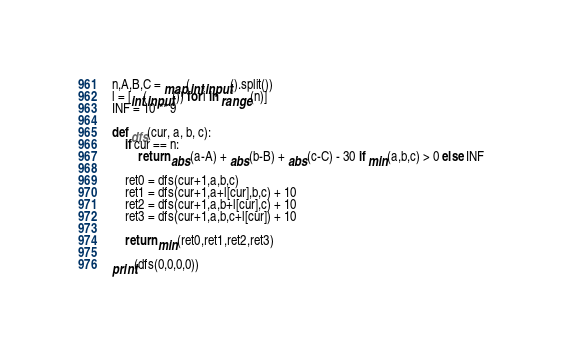Convert code to text. <code><loc_0><loc_0><loc_500><loc_500><_Python_>n,A,B,C = map(int,input().split())
l = [int(input()) for i in range(n)]
INF = 10 ** 9

def dfs(cur, a, b, c):
    if cur == n:
        return abs(a-A) + abs(b-B) + abs(c-C) - 30 if min(a,b,c) > 0 else INF
    
    ret0 = dfs(cur+1,a,b,c)
    ret1 = dfs(cur+1,a+l[cur],b,c) + 10
    ret2 = dfs(cur+1,a,b+l[cur],c) + 10
    ret3 = dfs(cur+1,a,b,c+l[cur]) + 10

    return min(ret0,ret1,ret2,ret3)

print(dfs(0,0,0,0))
</code> 